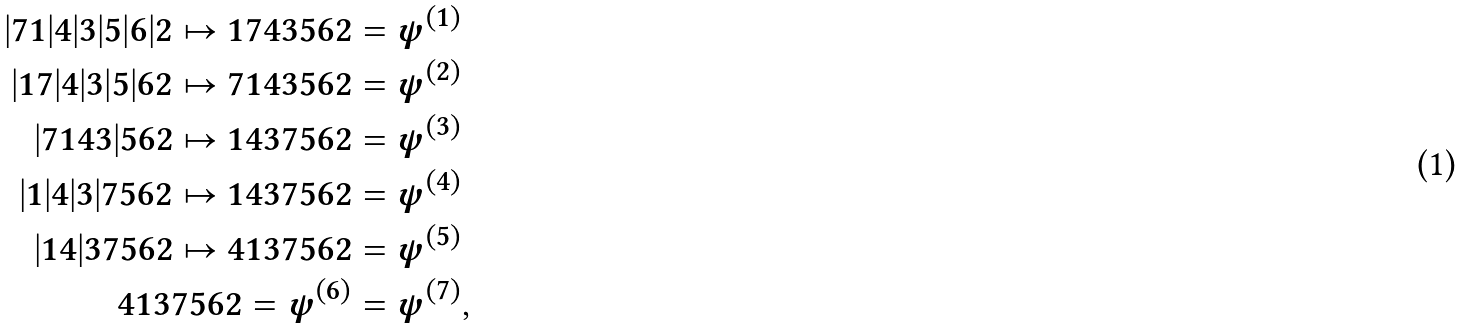Convert formula to latex. <formula><loc_0><loc_0><loc_500><loc_500>| 7 1 | 4 | 3 | 5 | 6 | 2 \mapsto 1 7 4 3 5 6 2 & = \psi ^ { ( 1 ) } \\ | 1 7 | 4 | 3 | 5 | 6 2 \mapsto 7 1 4 3 5 6 2 & = \psi ^ { ( 2 ) } \\ | 7 1 4 3 | 5 6 2 \mapsto 1 4 3 7 5 6 2 & = \psi ^ { ( 3 ) } \\ | 1 | 4 | 3 | 7 5 6 2 \mapsto 1 4 3 7 5 6 2 & = \psi ^ { ( 4 ) } \\ | 1 4 | 3 7 5 6 2 \mapsto 4 1 3 7 5 6 2 & = \psi ^ { ( 5 ) } \\ 4 1 3 7 5 6 2 = \psi ^ { ( 6 ) } & = \psi ^ { ( 7 ) } ,</formula> 